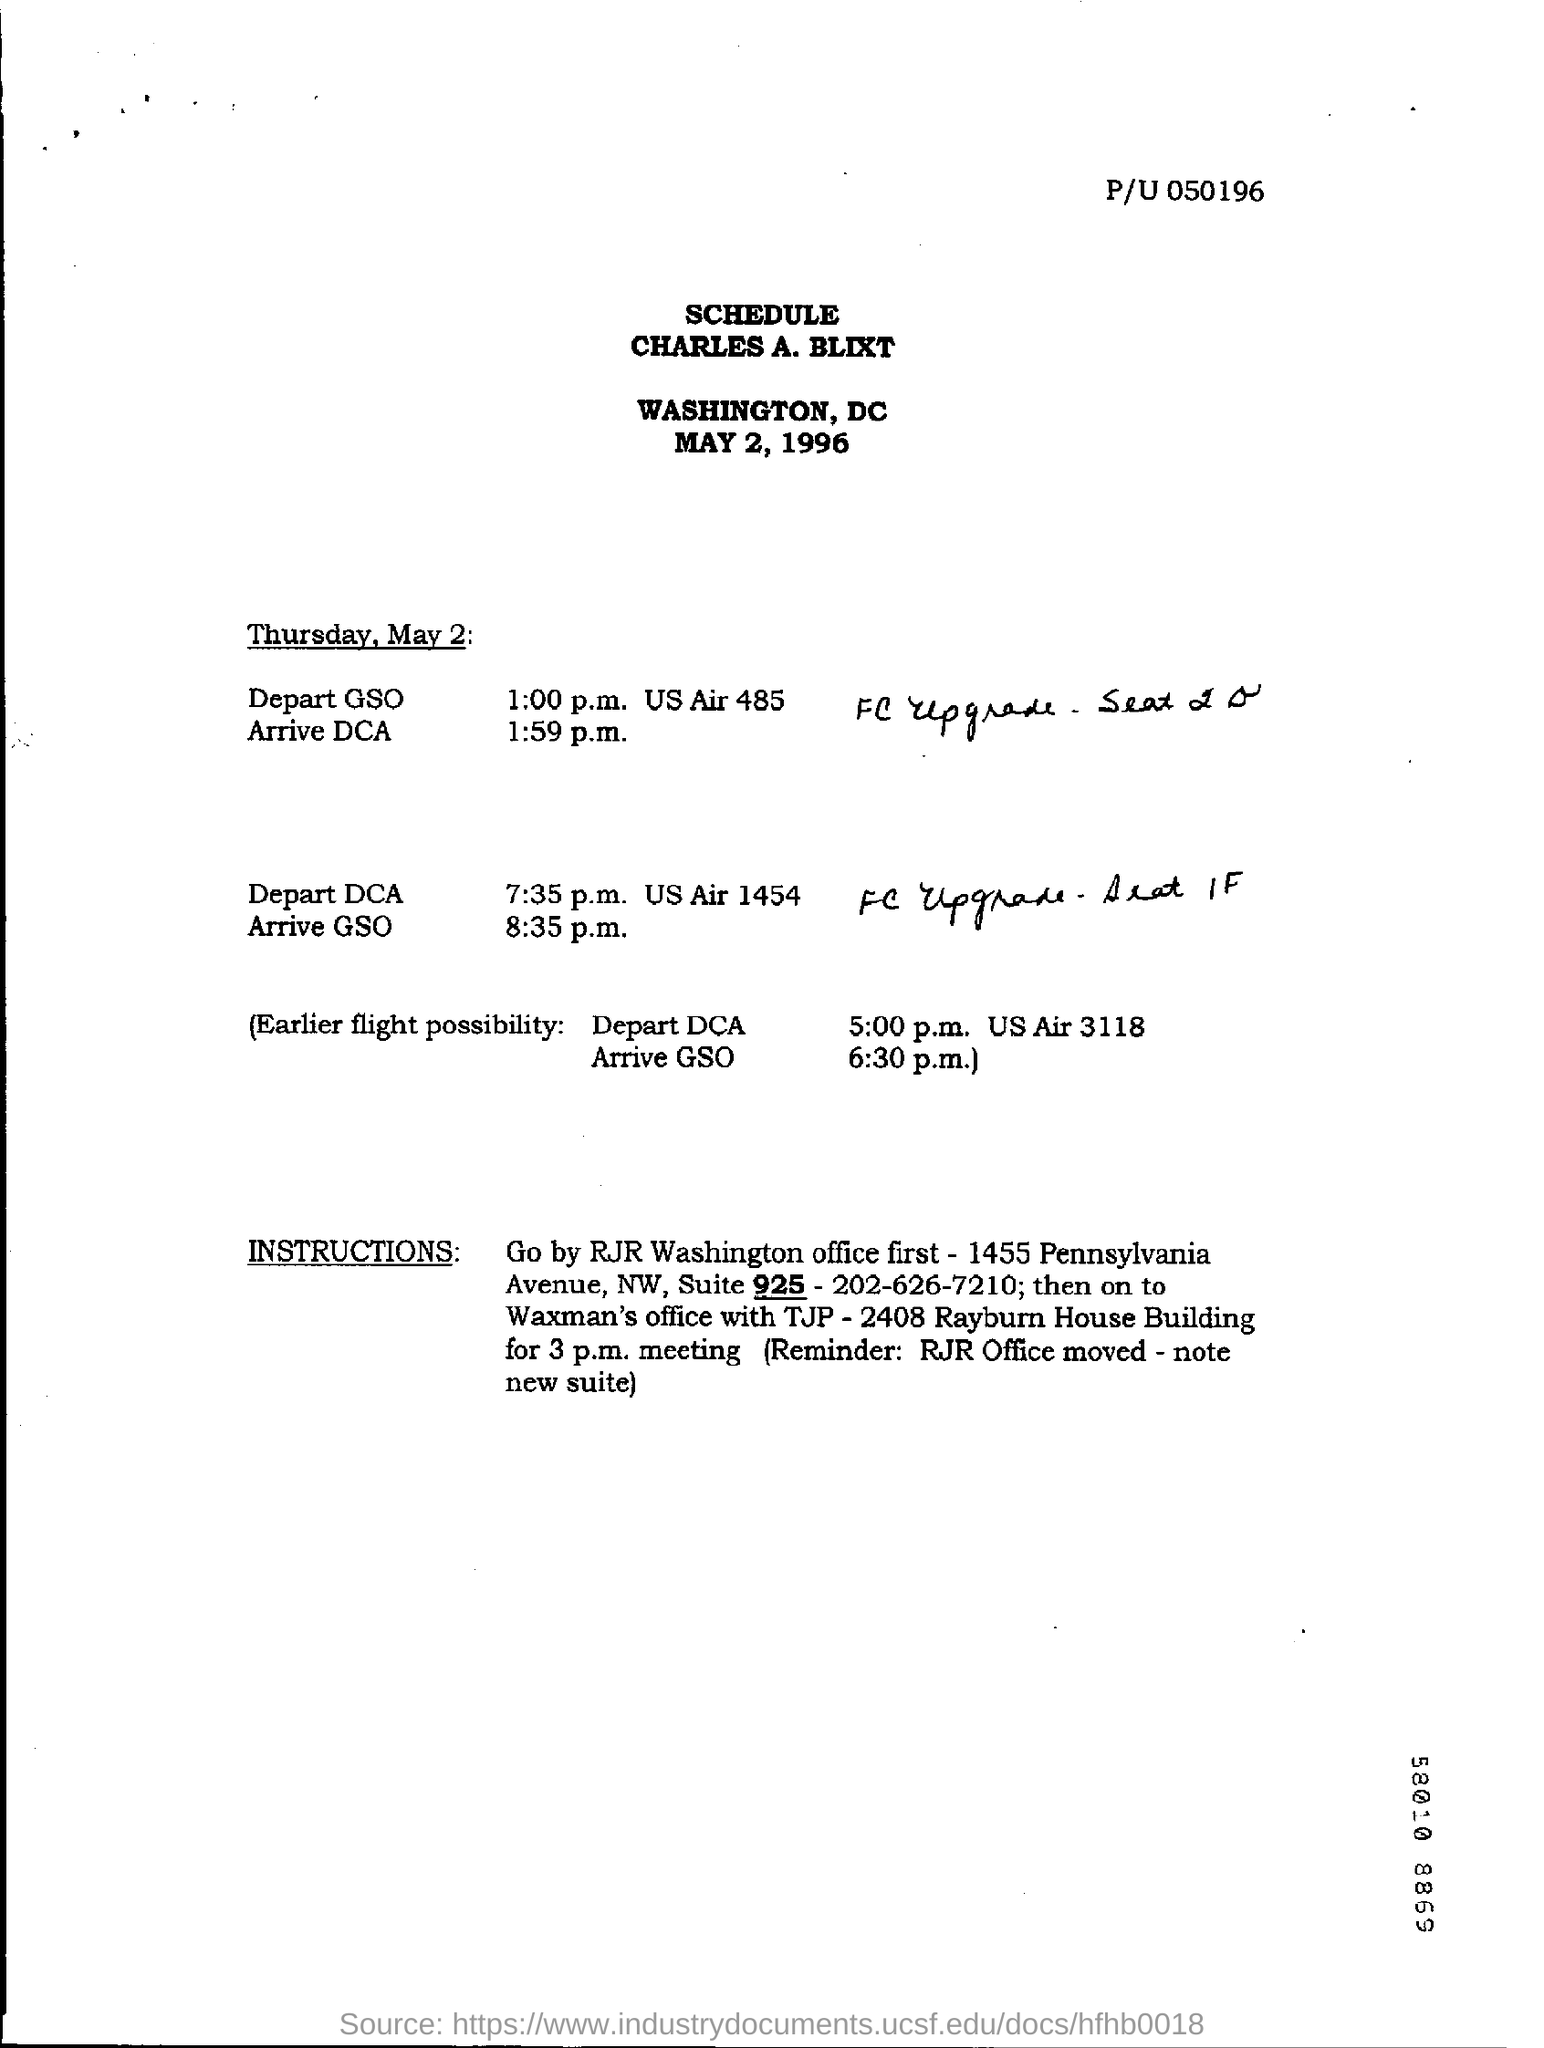What day of the week is may 2?
Keep it short and to the point. Thursday. What date is schedule prepared for ?
Your response must be concise. May 2, 1996. 